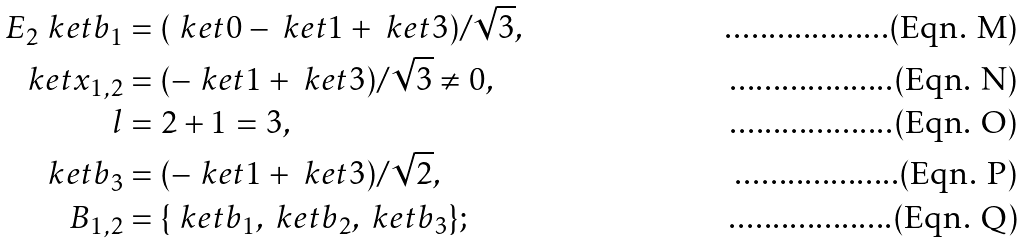<formula> <loc_0><loc_0><loc_500><loc_500>E _ { 2 } \ k e t { b _ { 1 } } & = ( \ k e t { 0 } - \ k e t { 1 } + \ k e t { 3 } ) / \sqrt { 3 } , \\ \ k e t { x _ { 1 , 2 } } & = ( - \ k e t { 1 } + \ k e t { 3 } ) / \sqrt { 3 } \neq 0 , \\ l & = 2 + 1 = 3 , \\ \ k e t { b _ { 3 } } & = ( - \ k e t { 1 } + \ k e t { 3 } ) / \sqrt { 2 } , \\ B _ { 1 , 2 } & = \{ \ k e t { b _ { 1 } } , \ k e t { b _ { 2 } } , \ k e t { b _ { 3 } } \} ;</formula> 